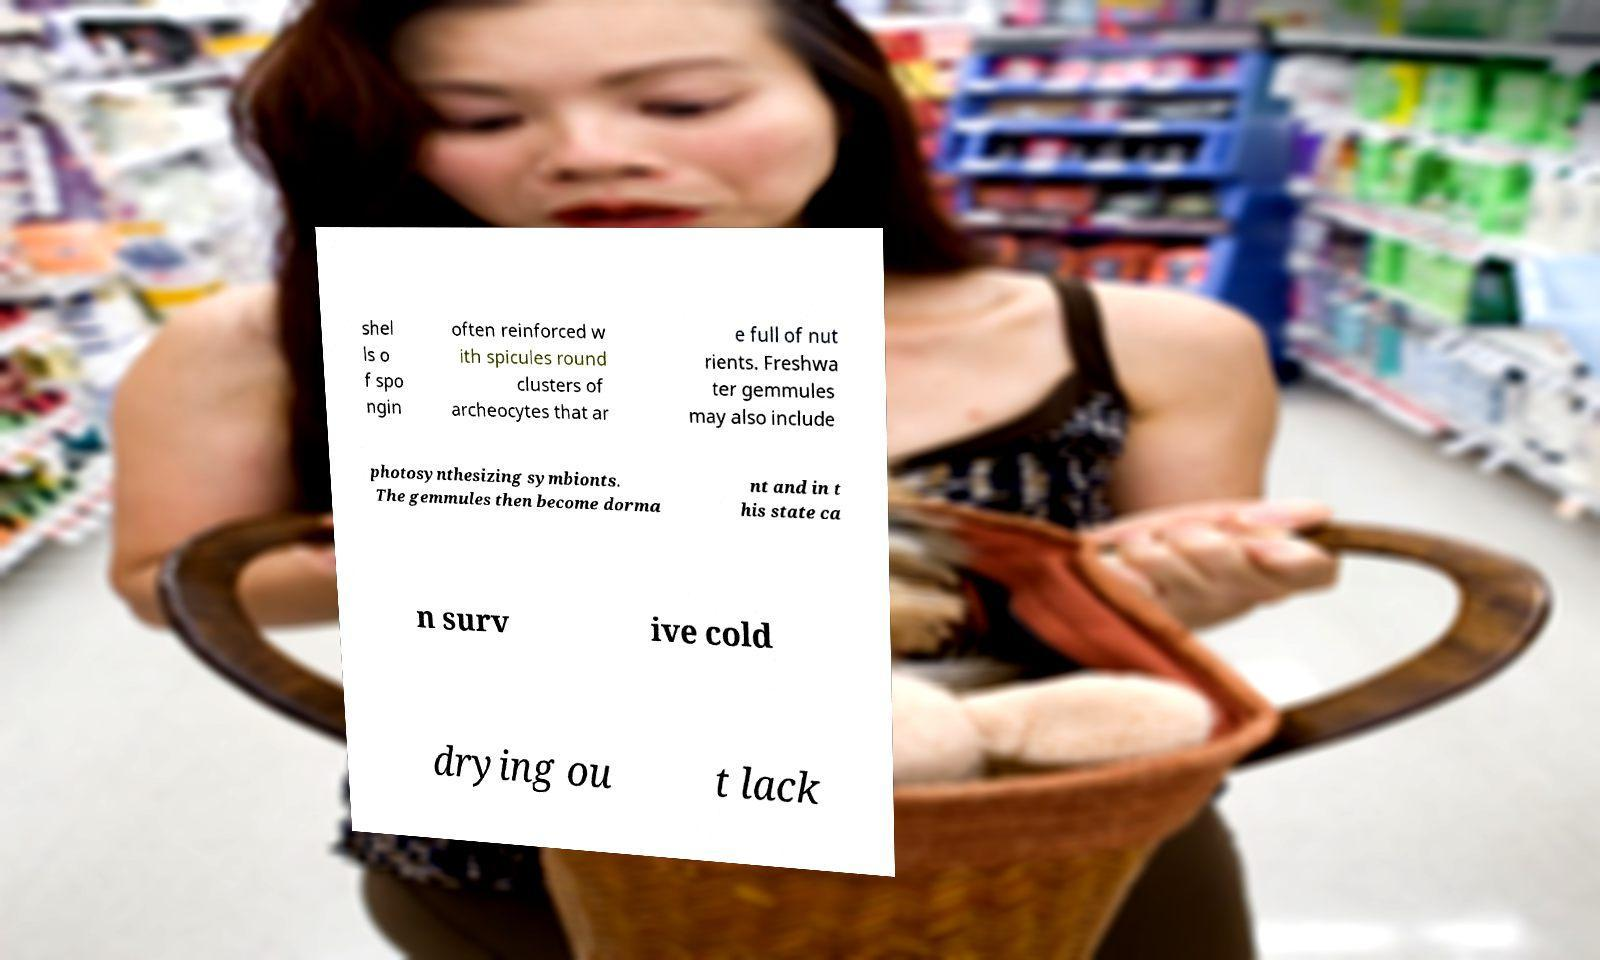Can you accurately transcribe the text from the provided image for me? shel ls o f spo ngin often reinforced w ith spicules round clusters of archeocytes that ar e full of nut rients. Freshwa ter gemmules may also include photosynthesizing symbionts. The gemmules then become dorma nt and in t his state ca n surv ive cold drying ou t lack 